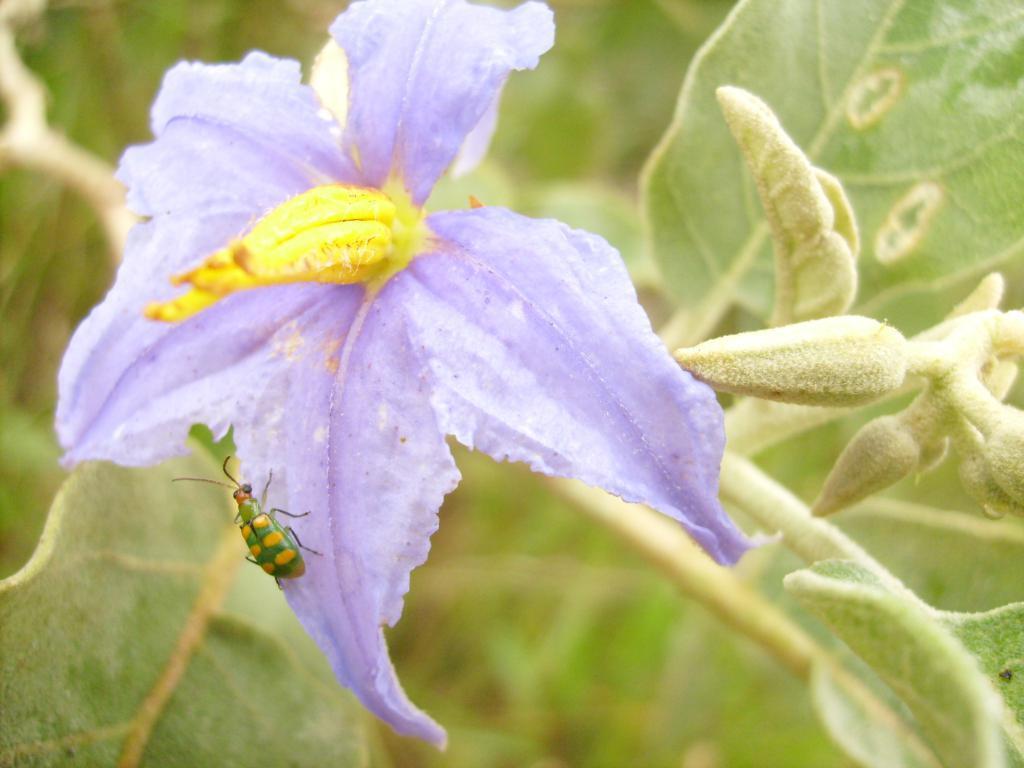In one or two sentences, can you explain what this image depicts? This image consists of a flower in purple color on which there is an insect. In the background, there are leaves and plants. 